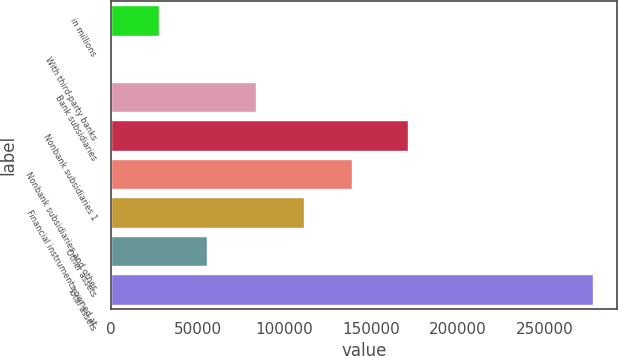<chart> <loc_0><loc_0><loc_500><loc_500><bar_chart><fcel>in millions<fcel>With third-party banks<fcel>Bank subsidiaries<fcel>Nonbank subsidiaries 1<fcel>Nonbank subsidiaries and other<fcel>Financial instruments owned at<fcel>Other assets<fcel>Total assets<nl><fcel>27865.3<fcel>42<fcel>83511.9<fcel>171121<fcel>139158<fcel>111335<fcel>55688.6<fcel>278275<nl></chart> 